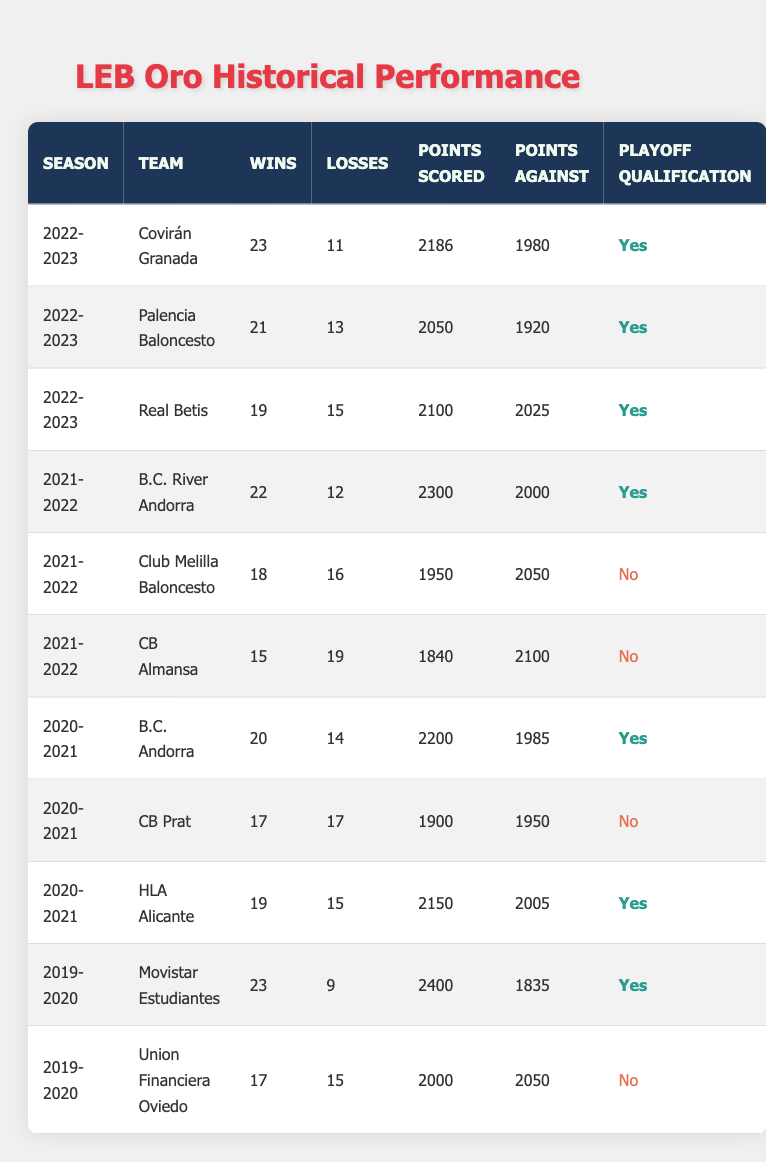What team had the highest number of wins in the 2022-2023 season? Covirán Granada recorded the highest wins in the 2022-2023 season with 23 wins. This can be directly seen in the table under the corresponding season.
Answer: Covirán Granada How many points did Palencia Baloncesto score in the 2022-2023 season? According to the table, Palencia Baloncesto scored 2050 points in the 2022-2023 season, which is listed directly in the "Points Scored" column for that team and season.
Answer: 2050 What was the total number of wins for teams that qualified for the playoffs in the 2021-2022 season? In the 2021-2022 season, the teams that qualified for the playoffs were B.C. River Andorra (22 wins), while Club Melilla Baloncesto and CB Almansa did not qualify. Adding the wins: 22. Therefore, total wins = 22.
Answer: 22 Did HLA Alicante qualify for the playoffs in the 2020-2021 season? Looking at the table, HLA Alicante is marked as "Yes" in the "Playoff Qualification" column, indicating that they did qualify for the playoffs that season.
Answer: Yes Which team had the lowest points scored in the 2021-2022 season? By examining the "Points Scored" column for the 2021-2022 season, CB Almansa scored the lowest with 1840 points, while B.C. River Andorra and Club Melilla Baloncesto scored higher. Therefore, CB Almansa had the lowest points scored.
Answer: CB Almansa What is the average number of wins for teams in the 2020-2021 season? The teams in the 2020-2021 season and their wins are as follows: B.C. Andorra (20), CB Prat (17), and HLA Alicante (19). To calculate the average: (20 + 17 + 19) = 56 total wins. There are 3 teams, so the average is 56/3 = approximately 18.67.
Answer: 18.67 How many teams had a losing record (more losses than wins) in the 2021-2022 season? In the 2021-2022 season, the teams with losing records were Club Melilla Baloncesto (18 wins, 16 losses) and CB Almansa (15 wins, 19 losses). CB Almansa has a losing record, but Club Melilla had 18 wins. Therefore, only 1 team had a losing record.
Answer: 1 What was the point difference for Movistar Estudiantes in the 2019-2020 season? Examining the "Points Scored" and "Points Against" columns, Movistar Estudiantes scored 2400 points and had 1835 points against. The point difference is calculated as scored - against: 2400 - 1835 = 565.
Answer: 565 How many teams qualified for the playoffs in the 2022-2023 season? In the 2022-2023 season, three teams—Covirán Granada, Palencia Baloncesto, and Real Betis—are marked as having qualified for the playoffs in the "Playoff Qualification" column. Therefore, the total is 3 teams.
Answer: 3 